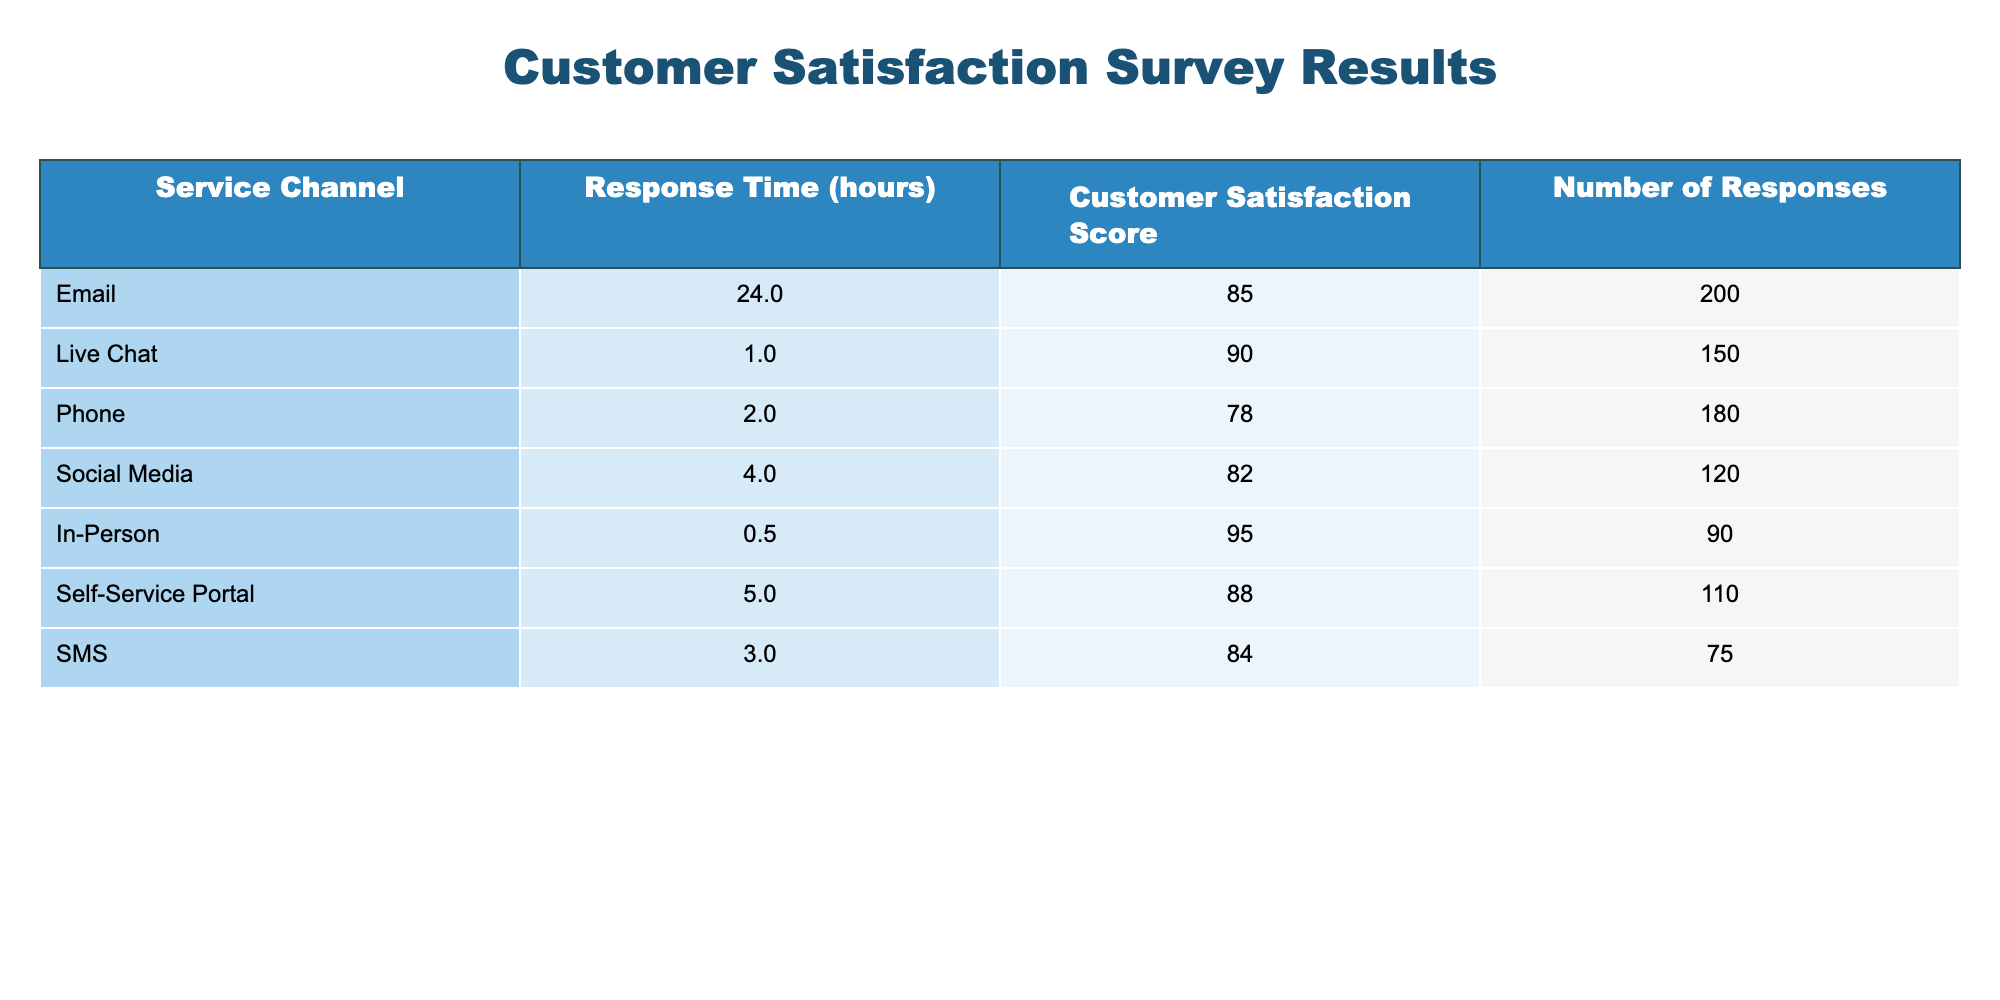What is the customer satisfaction score for the Live Chat service channel? The table lists the customer satisfaction scores for different service channels. For Live Chat, the score is explicitly mentioned in the corresponding row.
Answer: 90 Which service channel has the highest number of responses? To find the service channel with the highest number of responses, we compare the "Number of Responses" column. The highest value is 200, associated with the Email channel.
Answer: Email What is the average customer satisfaction score for all service channels? First, sum up all the customer satisfaction scores: (85 + 90 + 78 + 82 + 95 + 88 + 84) = 502. Then, divide by the number of channels (7): 502 / 7 = 71.7, which rounds to approximately 85.5.
Answer: 85.5 Is the customer satisfaction score for In-Person services higher than that for Phone services? Compare the scores directly: In-Person has a score of 95, while Phone has a score of 78. Since 95 is greater than 78, we conclude that In-Person's score is indeed higher.
Answer: Yes What is the total number of responses from the Self-Service Portal and SMS combined? To find the total, sum the "Number of Responses" for these two channels: Self-Service Portal has 110 responses and SMS has 75. Therefore, 110 + 75 = 185.
Answer: 185 Which service channel has the shortest response time? Examine the "Response Time (hours)" column for all channels. The shortest response time is mentioned for In-Person services at 0.5 hours.
Answer: In-Person How does the customer satisfaction score of Email compare to that of SMS? Compare the scores in the corresponding rows: Email has a score of 85, and SMS has a score of 84. Since 85 is higher than 84, Email has a better score than SMS.
Answer: Email is higher If we categorize services with a satisfaction score above 85, how many service channels fall into this category? Review the scores for each channel and count those above 85: In-Person (95), Live Chat (90), and Self-Service Portal (88) qualify. This results in a total of 3 channels.
Answer: 3 What is the difference in customer satisfaction scores between the highest and lowest scoring channels? Identify the highest scoring channel, In-Person at 95, and the lowest, Phone at 78. The difference is calculated by subtracting the lower score from the higher score: 95 - 78 = 17.
Answer: 17 